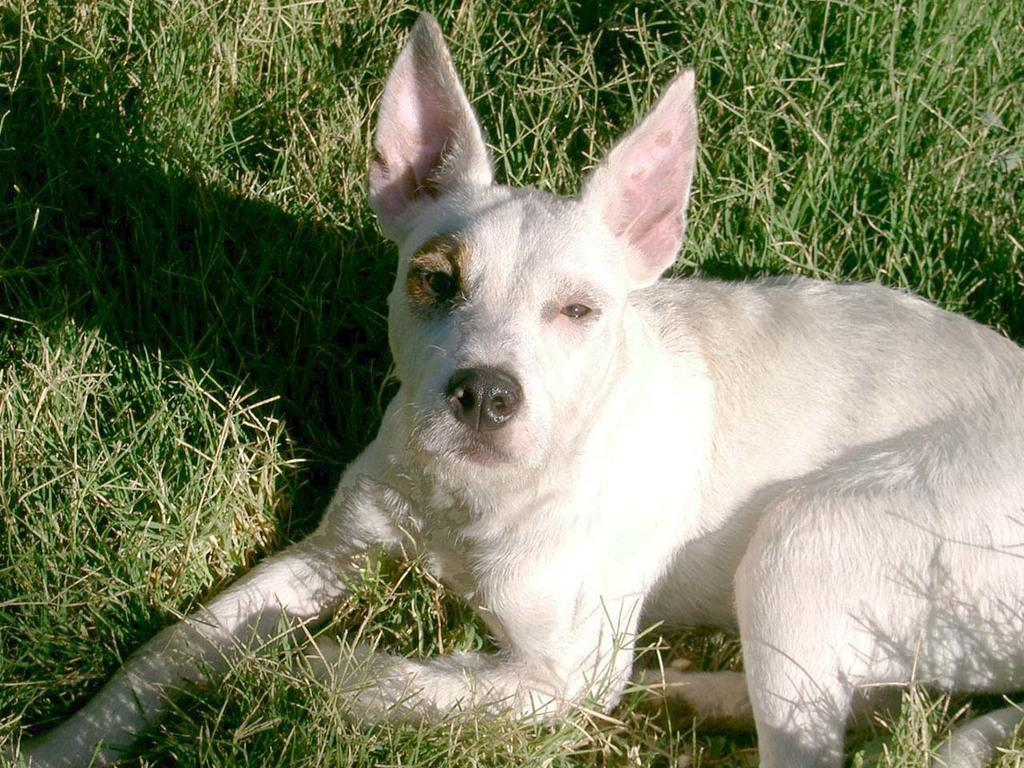What type of animal is in the picture? There is an animal in the picture, but the specific type cannot be determined from the provided facts. Where is the animal located in the image? The animal is sitting on the grass. What is the color of the animal in the image? The animal is white in color. What time of day is depicted in the image with the kite flying in the background? There is no kite present in the image, so it is not possible to determine the time of day based on that information. 